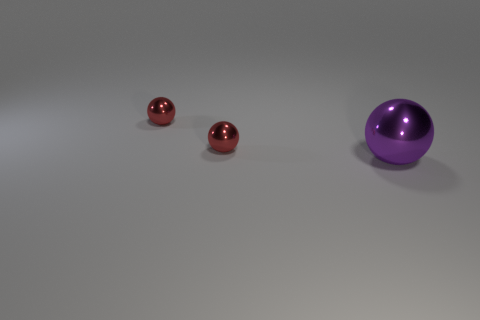Add 1 red things. How many objects exist? 4 Add 1 big purple metallic balls. How many big purple metallic balls exist? 2 Subtract 0 yellow spheres. How many objects are left? 3 Subtract all small objects. Subtract all large purple things. How many objects are left? 0 Add 3 large purple balls. How many large purple balls are left? 4 